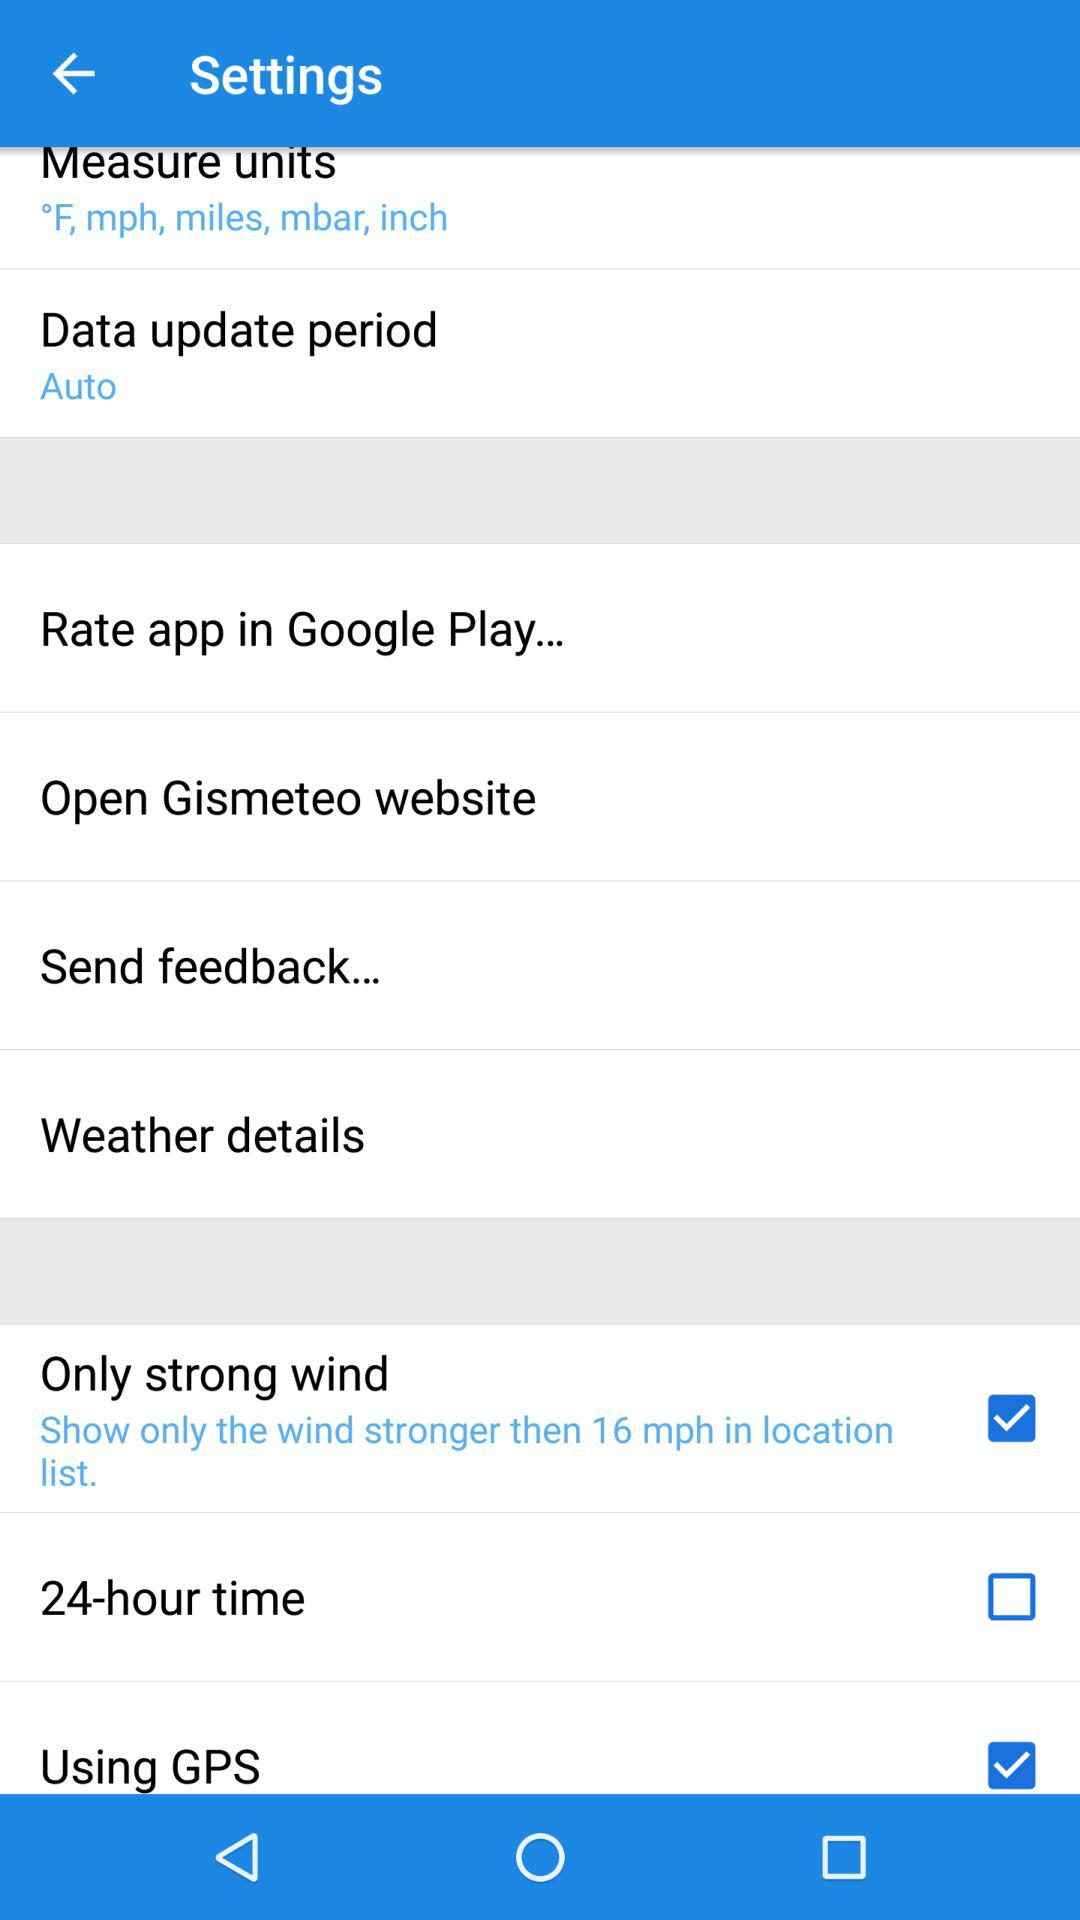What is the speed of wind at which a strong wind alert will be shown? A strong wind alert will be shown at winds stronger than 16 mph. 